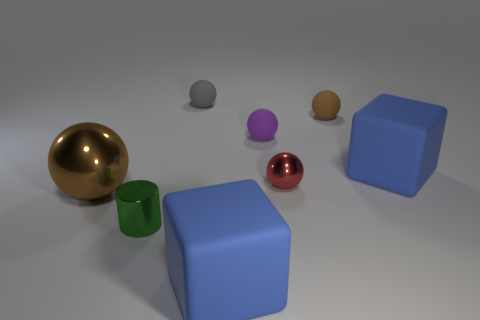Add 2 matte blocks. How many objects exist? 10 Subtract all brown metal spheres. How many spheres are left? 4 Subtract 1 cubes. How many cubes are left? 1 Subtract all purple balls. How many balls are left? 4 Subtract all red cylinders. Subtract all cyan blocks. How many cylinders are left? 1 Subtract all gray cylinders. How many purple spheres are left? 1 Subtract all cylinders. Subtract all big spheres. How many objects are left? 6 Add 6 large objects. How many large objects are left? 9 Add 3 big brown metallic things. How many big brown metallic things exist? 4 Subtract 0 green cubes. How many objects are left? 8 